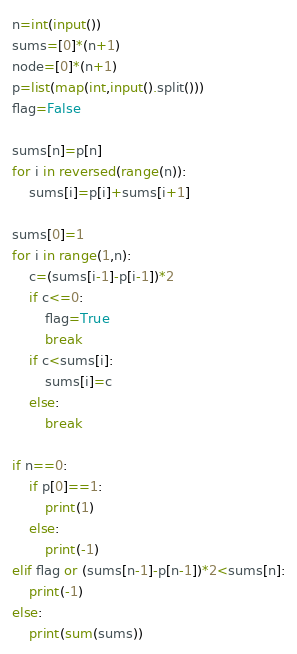Convert code to text. <code><loc_0><loc_0><loc_500><loc_500><_Python_>n=int(input())
sums=[0]*(n+1)
node=[0]*(n+1)
p=list(map(int,input().split()))
flag=False

sums[n]=p[n]
for i in reversed(range(n)):
    sums[i]=p[i]+sums[i+1]

sums[0]=1
for i in range(1,n):
    c=(sums[i-1]-p[i-1])*2
    if c<=0:
        flag=True
        break
    if c<sums[i]:
        sums[i]=c
    else:
        break

if n==0:
    if p[0]==1:
        print(1)
    else:
        print(-1)
elif flag or (sums[n-1]-p[n-1])*2<sums[n]:
    print(-1)
else:
    print(sum(sums))</code> 